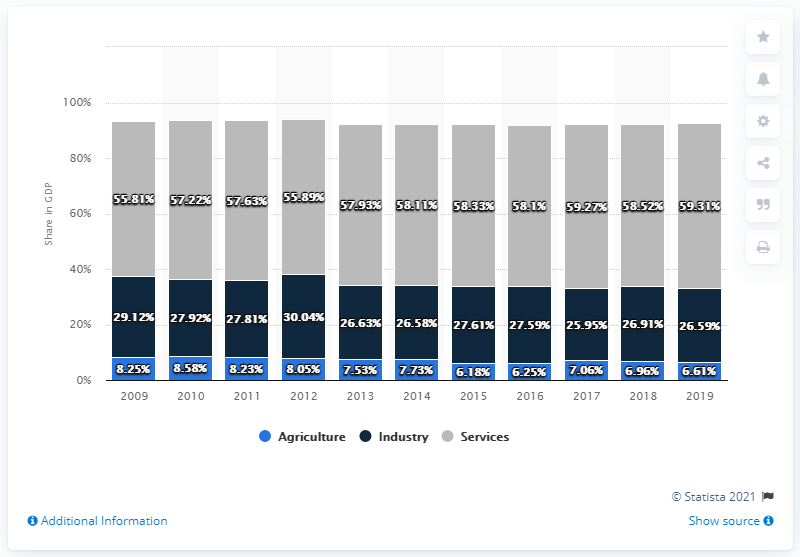Draw attention to some important aspects in this diagram. The average value of the blue bar for the years 2018 and 2019 is 6.78. The highest percentage shown in the blue bar is 8.58%. 